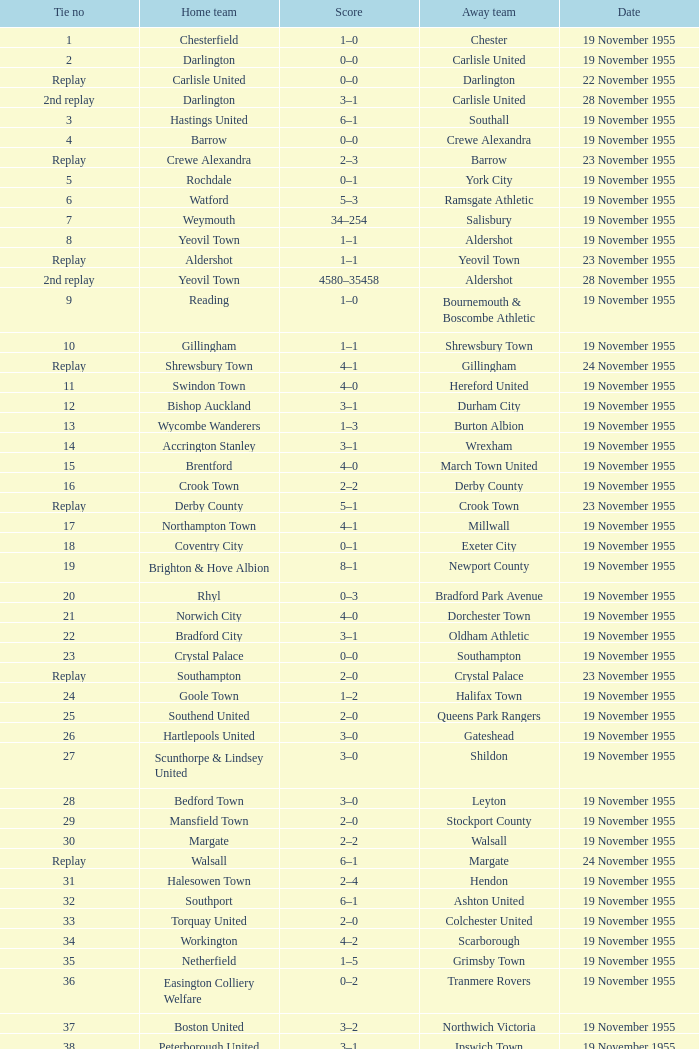What is the home team with scarborough as the away team? Workington. 